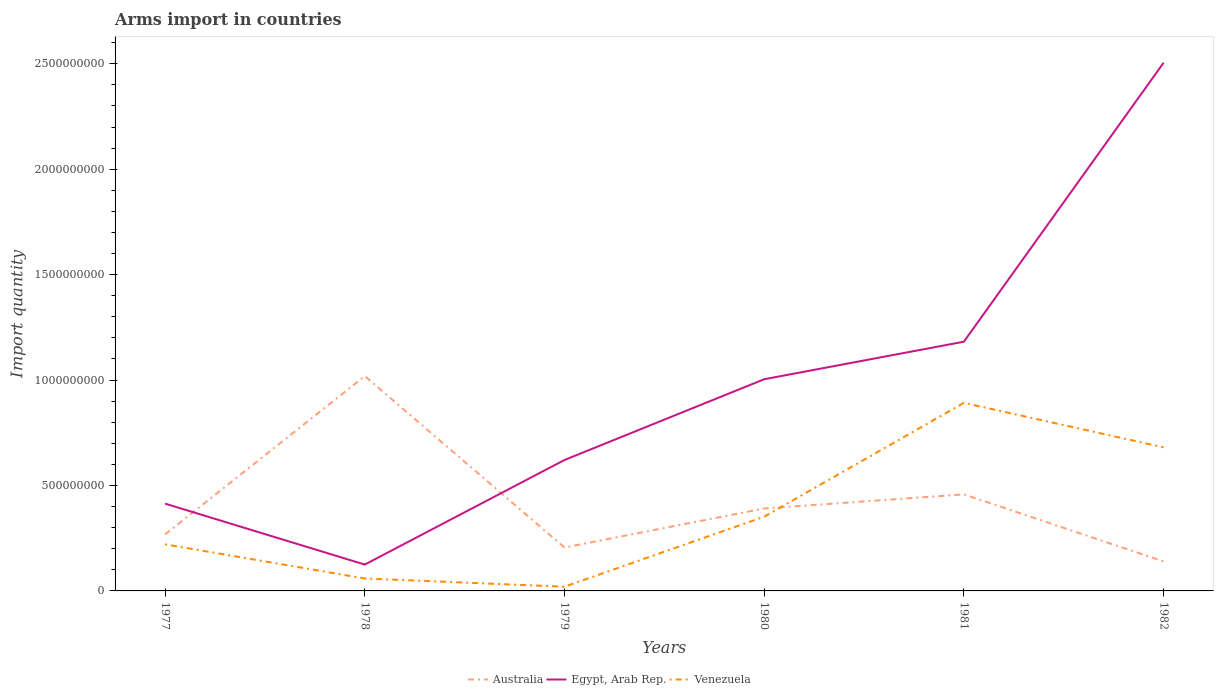Does the line corresponding to Egypt, Arab Rep. intersect with the line corresponding to Australia?
Your response must be concise. Yes. Is the number of lines equal to the number of legend labels?
Offer a very short reply. Yes. Across all years, what is the maximum total arms import in Egypt, Arab Rep.?
Your answer should be compact. 1.25e+08. In which year was the total arms import in Egypt, Arab Rep. maximum?
Provide a short and direct response. 1978. What is the total total arms import in Venezuela in the graph?
Offer a very short reply. -6.61e+08. What is the difference between the highest and the second highest total arms import in Australia?
Keep it short and to the point. 8.79e+08. How many lines are there?
Offer a terse response. 3. What is the difference between two consecutive major ticks on the Y-axis?
Ensure brevity in your answer.  5.00e+08. Are the values on the major ticks of Y-axis written in scientific E-notation?
Keep it short and to the point. No. Does the graph contain grids?
Keep it short and to the point. No. Where does the legend appear in the graph?
Give a very brief answer. Bottom center. What is the title of the graph?
Make the answer very short. Arms import in countries. What is the label or title of the X-axis?
Your answer should be compact. Years. What is the label or title of the Y-axis?
Provide a succinct answer. Import quantity. What is the Import quantity in Australia in 1977?
Offer a very short reply. 2.68e+08. What is the Import quantity in Egypt, Arab Rep. in 1977?
Your answer should be compact. 4.14e+08. What is the Import quantity in Venezuela in 1977?
Your answer should be very brief. 2.21e+08. What is the Import quantity of Australia in 1978?
Offer a very short reply. 1.02e+09. What is the Import quantity of Egypt, Arab Rep. in 1978?
Provide a short and direct response. 1.25e+08. What is the Import quantity of Venezuela in 1978?
Keep it short and to the point. 5.90e+07. What is the Import quantity in Australia in 1979?
Give a very brief answer. 2.06e+08. What is the Import quantity in Egypt, Arab Rep. in 1979?
Offer a very short reply. 6.21e+08. What is the Import quantity of Australia in 1980?
Provide a succinct answer. 3.91e+08. What is the Import quantity in Egypt, Arab Rep. in 1980?
Provide a short and direct response. 1.00e+09. What is the Import quantity in Venezuela in 1980?
Ensure brevity in your answer.  3.52e+08. What is the Import quantity in Australia in 1981?
Provide a short and direct response. 4.58e+08. What is the Import quantity in Egypt, Arab Rep. in 1981?
Your answer should be very brief. 1.18e+09. What is the Import quantity in Venezuela in 1981?
Offer a very short reply. 8.92e+08. What is the Import quantity in Australia in 1982?
Your response must be concise. 1.40e+08. What is the Import quantity in Egypt, Arab Rep. in 1982?
Ensure brevity in your answer.  2.50e+09. What is the Import quantity of Venezuela in 1982?
Your response must be concise. 6.81e+08. Across all years, what is the maximum Import quantity in Australia?
Keep it short and to the point. 1.02e+09. Across all years, what is the maximum Import quantity in Egypt, Arab Rep.?
Give a very brief answer. 2.50e+09. Across all years, what is the maximum Import quantity in Venezuela?
Offer a terse response. 8.92e+08. Across all years, what is the minimum Import quantity of Australia?
Provide a succinct answer. 1.40e+08. Across all years, what is the minimum Import quantity in Egypt, Arab Rep.?
Your response must be concise. 1.25e+08. Across all years, what is the minimum Import quantity of Venezuela?
Your answer should be very brief. 2.00e+07. What is the total Import quantity of Australia in the graph?
Your response must be concise. 2.48e+09. What is the total Import quantity of Egypt, Arab Rep. in the graph?
Your answer should be very brief. 5.85e+09. What is the total Import quantity in Venezuela in the graph?
Offer a very short reply. 2.22e+09. What is the difference between the Import quantity of Australia in 1977 and that in 1978?
Your answer should be very brief. -7.51e+08. What is the difference between the Import quantity in Egypt, Arab Rep. in 1977 and that in 1978?
Make the answer very short. 2.89e+08. What is the difference between the Import quantity in Venezuela in 1977 and that in 1978?
Give a very brief answer. 1.62e+08. What is the difference between the Import quantity in Australia in 1977 and that in 1979?
Offer a terse response. 6.20e+07. What is the difference between the Import quantity in Egypt, Arab Rep. in 1977 and that in 1979?
Provide a short and direct response. -2.07e+08. What is the difference between the Import quantity of Venezuela in 1977 and that in 1979?
Your answer should be very brief. 2.01e+08. What is the difference between the Import quantity in Australia in 1977 and that in 1980?
Ensure brevity in your answer.  -1.23e+08. What is the difference between the Import quantity of Egypt, Arab Rep. in 1977 and that in 1980?
Provide a short and direct response. -5.90e+08. What is the difference between the Import quantity of Venezuela in 1977 and that in 1980?
Ensure brevity in your answer.  -1.31e+08. What is the difference between the Import quantity in Australia in 1977 and that in 1981?
Your answer should be compact. -1.90e+08. What is the difference between the Import quantity of Egypt, Arab Rep. in 1977 and that in 1981?
Offer a very short reply. -7.68e+08. What is the difference between the Import quantity in Venezuela in 1977 and that in 1981?
Provide a succinct answer. -6.71e+08. What is the difference between the Import quantity in Australia in 1977 and that in 1982?
Offer a terse response. 1.28e+08. What is the difference between the Import quantity in Egypt, Arab Rep. in 1977 and that in 1982?
Your answer should be compact. -2.09e+09. What is the difference between the Import quantity of Venezuela in 1977 and that in 1982?
Your response must be concise. -4.60e+08. What is the difference between the Import quantity in Australia in 1978 and that in 1979?
Give a very brief answer. 8.13e+08. What is the difference between the Import quantity of Egypt, Arab Rep. in 1978 and that in 1979?
Give a very brief answer. -4.96e+08. What is the difference between the Import quantity in Venezuela in 1978 and that in 1979?
Give a very brief answer. 3.90e+07. What is the difference between the Import quantity in Australia in 1978 and that in 1980?
Offer a very short reply. 6.28e+08. What is the difference between the Import quantity of Egypt, Arab Rep. in 1978 and that in 1980?
Ensure brevity in your answer.  -8.79e+08. What is the difference between the Import quantity in Venezuela in 1978 and that in 1980?
Your answer should be very brief. -2.93e+08. What is the difference between the Import quantity of Australia in 1978 and that in 1981?
Make the answer very short. 5.61e+08. What is the difference between the Import quantity in Egypt, Arab Rep. in 1978 and that in 1981?
Provide a succinct answer. -1.06e+09. What is the difference between the Import quantity of Venezuela in 1978 and that in 1981?
Offer a terse response. -8.33e+08. What is the difference between the Import quantity of Australia in 1978 and that in 1982?
Make the answer very short. 8.79e+08. What is the difference between the Import quantity in Egypt, Arab Rep. in 1978 and that in 1982?
Provide a short and direct response. -2.38e+09. What is the difference between the Import quantity of Venezuela in 1978 and that in 1982?
Provide a short and direct response. -6.22e+08. What is the difference between the Import quantity of Australia in 1979 and that in 1980?
Offer a very short reply. -1.85e+08. What is the difference between the Import quantity of Egypt, Arab Rep. in 1979 and that in 1980?
Your answer should be very brief. -3.83e+08. What is the difference between the Import quantity of Venezuela in 1979 and that in 1980?
Offer a terse response. -3.32e+08. What is the difference between the Import quantity in Australia in 1979 and that in 1981?
Ensure brevity in your answer.  -2.52e+08. What is the difference between the Import quantity of Egypt, Arab Rep. in 1979 and that in 1981?
Provide a succinct answer. -5.61e+08. What is the difference between the Import quantity in Venezuela in 1979 and that in 1981?
Offer a terse response. -8.72e+08. What is the difference between the Import quantity of Australia in 1979 and that in 1982?
Offer a very short reply. 6.60e+07. What is the difference between the Import quantity of Egypt, Arab Rep. in 1979 and that in 1982?
Your answer should be very brief. -1.88e+09. What is the difference between the Import quantity in Venezuela in 1979 and that in 1982?
Your answer should be very brief. -6.61e+08. What is the difference between the Import quantity in Australia in 1980 and that in 1981?
Make the answer very short. -6.70e+07. What is the difference between the Import quantity of Egypt, Arab Rep. in 1980 and that in 1981?
Offer a terse response. -1.78e+08. What is the difference between the Import quantity of Venezuela in 1980 and that in 1981?
Provide a short and direct response. -5.40e+08. What is the difference between the Import quantity of Australia in 1980 and that in 1982?
Provide a succinct answer. 2.51e+08. What is the difference between the Import quantity in Egypt, Arab Rep. in 1980 and that in 1982?
Your answer should be very brief. -1.50e+09. What is the difference between the Import quantity of Venezuela in 1980 and that in 1982?
Your response must be concise. -3.29e+08. What is the difference between the Import quantity in Australia in 1981 and that in 1982?
Your answer should be compact. 3.18e+08. What is the difference between the Import quantity in Egypt, Arab Rep. in 1981 and that in 1982?
Provide a short and direct response. -1.32e+09. What is the difference between the Import quantity in Venezuela in 1981 and that in 1982?
Give a very brief answer. 2.11e+08. What is the difference between the Import quantity of Australia in 1977 and the Import quantity of Egypt, Arab Rep. in 1978?
Your answer should be very brief. 1.43e+08. What is the difference between the Import quantity in Australia in 1977 and the Import quantity in Venezuela in 1978?
Keep it short and to the point. 2.09e+08. What is the difference between the Import quantity in Egypt, Arab Rep. in 1977 and the Import quantity in Venezuela in 1978?
Your response must be concise. 3.55e+08. What is the difference between the Import quantity in Australia in 1977 and the Import quantity in Egypt, Arab Rep. in 1979?
Make the answer very short. -3.53e+08. What is the difference between the Import quantity in Australia in 1977 and the Import quantity in Venezuela in 1979?
Make the answer very short. 2.48e+08. What is the difference between the Import quantity of Egypt, Arab Rep. in 1977 and the Import quantity of Venezuela in 1979?
Ensure brevity in your answer.  3.94e+08. What is the difference between the Import quantity in Australia in 1977 and the Import quantity in Egypt, Arab Rep. in 1980?
Provide a short and direct response. -7.36e+08. What is the difference between the Import quantity in Australia in 1977 and the Import quantity in Venezuela in 1980?
Offer a terse response. -8.40e+07. What is the difference between the Import quantity in Egypt, Arab Rep. in 1977 and the Import quantity in Venezuela in 1980?
Give a very brief answer. 6.20e+07. What is the difference between the Import quantity of Australia in 1977 and the Import quantity of Egypt, Arab Rep. in 1981?
Give a very brief answer. -9.14e+08. What is the difference between the Import quantity in Australia in 1977 and the Import quantity in Venezuela in 1981?
Provide a short and direct response. -6.24e+08. What is the difference between the Import quantity of Egypt, Arab Rep. in 1977 and the Import quantity of Venezuela in 1981?
Give a very brief answer. -4.78e+08. What is the difference between the Import quantity in Australia in 1977 and the Import quantity in Egypt, Arab Rep. in 1982?
Provide a short and direct response. -2.24e+09. What is the difference between the Import quantity in Australia in 1977 and the Import quantity in Venezuela in 1982?
Provide a short and direct response. -4.13e+08. What is the difference between the Import quantity of Egypt, Arab Rep. in 1977 and the Import quantity of Venezuela in 1982?
Your answer should be compact. -2.67e+08. What is the difference between the Import quantity of Australia in 1978 and the Import quantity of Egypt, Arab Rep. in 1979?
Offer a very short reply. 3.98e+08. What is the difference between the Import quantity of Australia in 1978 and the Import quantity of Venezuela in 1979?
Make the answer very short. 9.99e+08. What is the difference between the Import quantity in Egypt, Arab Rep. in 1978 and the Import quantity in Venezuela in 1979?
Ensure brevity in your answer.  1.05e+08. What is the difference between the Import quantity in Australia in 1978 and the Import quantity in Egypt, Arab Rep. in 1980?
Offer a terse response. 1.50e+07. What is the difference between the Import quantity of Australia in 1978 and the Import quantity of Venezuela in 1980?
Give a very brief answer. 6.67e+08. What is the difference between the Import quantity of Egypt, Arab Rep. in 1978 and the Import quantity of Venezuela in 1980?
Give a very brief answer. -2.27e+08. What is the difference between the Import quantity of Australia in 1978 and the Import quantity of Egypt, Arab Rep. in 1981?
Your answer should be very brief. -1.63e+08. What is the difference between the Import quantity of Australia in 1978 and the Import quantity of Venezuela in 1981?
Offer a very short reply. 1.27e+08. What is the difference between the Import quantity in Egypt, Arab Rep. in 1978 and the Import quantity in Venezuela in 1981?
Give a very brief answer. -7.67e+08. What is the difference between the Import quantity of Australia in 1978 and the Import quantity of Egypt, Arab Rep. in 1982?
Provide a succinct answer. -1.49e+09. What is the difference between the Import quantity in Australia in 1978 and the Import quantity in Venezuela in 1982?
Offer a terse response. 3.38e+08. What is the difference between the Import quantity in Egypt, Arab Rep. in 1978 and the Import quantity in Venezuela in 1982?
Give a very brief answer. -5.56e+08. What is the difference between the Import quantity in Australia in 1979 and the Import quantity in Egypt, Arab Rep. in 1980?
Give a very brief answer. -7.98e+08. What is the difference between the Import quantity of Australia in 1979 and the Import quantity of Venezuela in 1980?
Your answer should be very brief. -1.46e+08. What is the difference between the Import quantity of Egypt, Arab Rep. in 1979 and the Import quantity of Venezuela in 1980?
Your answer should be very brief. 2.69e+08. What is the difference between the Import quantity in Australia in 1979 and the Import quantity in Egypt, Arab Rep. in 1981?
Your response must be concise. -9.76e+08. What is the difference between the Import quantity in Australia in 1979 and the Import quantity in Venezuela in 1981?
Make the answer very short. -6.86e+08. What is the difference between the Import quantity of Egypt, Arab Rep. in 1979 and the Import quantity of Venezuela in 1981?
Offer a terse response. -2.71e+08. What is the difference between the Import quantity of Australia in 1979 and the Import quantity of Egypt, Arab Rep. in 1982?
Make the answer very short. -2.30e+09. What is the difference between the Import quantity in Australia in 1979 and the Import quantity in Venezuela in 1982?
Your answer should be very brief. -4.75e+08. What is the difference between the Import quantity of Egypt, Arab Rep. in 1979 and the Import quantity of Venezuela in 1982?
Your response must be concise. -6.00e+07. What is the difference between the Import quantity of Australia in 1980 and the Import quantity of Egypt, Arab Rep. in 1981?
Ensure brevity in your answer.  -7.91e+08. What is the difference between the Import quantity of Australia in 1980 and the Import quantity of Venezuela in 1981?
Give a very brief answer. -5.01e+08. What is the difference between the Import quantity of Egypt, Arab Rep. in 1980 and the Import quantity of Venezuela in 1981?
Your answer should be compact. 1.12e+08. What is the difference between the Import quantity of Australia in 1980 and the Import quantity of Egypt, Arab Rep. in 1982?
Your answer should be compact. -2.11e+09. What is the difference between the Import quantity of Australia in 1980 and the Import quantity of Venezuela in 1982?
Keep it short and to the point. -2.90e+08. What is the difference between the Import quantity in Egypt, Arab Rep. in 1980 and the Import quantity in Venezuela in 1982?
Provide a short and direct response. 3.23e+08. What is the difference between the Import quantity in Australia in 1981 and the Import quantity in Egypt, Arab Rep. in 1982?
Keep it short and to the point. -2.05e+09. What is the difference between the Import quantity of Australia in 1981 and the Import quantity of Venezuela in 1982?
Keep it short and to the point. -2.23e+08. What is the difference between the Import quantity in Egypt, Arab Rep. in 1981 and the Import quantity in Venezuela in 1982?
Your answer should be compact. 5.01e+08. What is the average Import quantity of Australia per year?
Give a very brief answer. 4.14e+08. What is the average Import quantity in Egypt, Arab Rep. per year?
Your answer should be compact. 9.75e+08. What is the average Import quantity of Venezuela per year?
Provide a succinct answer. 3.71e+08. In the year 1977, what is the difference between the Import quantity of Australia and Import quantity of Egypt, Arab Rep.?
Your answer should be compact. -1.46e+08. In the year 1977, what is the difference between the Import quantity of Australia and Import quantity of Venezuela?
Keep it short and to the point. 4.70e+07. In the year 1977, what is the difference between the Import quantity in Egypt, Arab Rep. and Import quantity in Venezuela?
Make the answer very short. 1.93e+08. In the year 1978, what is the difference between the Import quantity of Australia and Import quantity of Egypt, Arab Rep.?
Your answer should be very brief. 8.94e+08. In the year 1978, what is the difference between the Import quantity of Australia and Import quantity of Venezuela?
Keep it short and to the point. 9.60e+08. In the year 1978, what is the difference between the Import quantity of Egypt, Arab Rep. and Import quantity of Venezuela?
Provide a short and direct response. 6.60e+07. In the year 1979, what is the difference between the Import quantity of Australia and Import quantity of Egypt, Arab Rep.?
Make the answer very short. -4.15e+08. In the year 1979, what is the difference between the Import quantity in Australia and Import quantity in Venezuela?
Offer a terse response. 1.86e+08. In the year 1979, what is the difference between the Import quantity of Egypt, Arab Rep. and Import quantity of Venezuela?
Keep it short and to the point. 6.01e+08. In the year 1980, what is the difference between the Import quantity of Australia and Import quantity of Egypt, Arab Rep.?
Your response must be concise. -6.13e+08. In the year 1980, what is the difference between the Import quantity in Australia and Import quantity in Venezuela?
Offer a very short reply. 3.90e+07. In the year 1980, what is the difference between the Import quantity of Egypt, Arab Rep. and Import quantity of Venezuela?
Your response must be concise. 6.52e+08. In the year 1981, what is the difference between the Import quantity in Australia and Import quantity in Egypt, Arab Rep.?
Provide a succinct answer. -7.24e+08. In the year 1981, what is the difference between the Import quantity of Australia and Import quantity of Venezuela?
Provide a succinct answer. -4.34e+08. In the year 1981, what is the difference between the Import quantity of Egypt, Arab Rep. and Import quantity of Venezuela?
Your response must be concise. 2.90e+08. In the year 1982, what is the difference between the Import quantity in Australia and Import quantity in Egypt, Arab Rep.?
Provide a succinct answer. -2.36e+09. In the year 1982, what is the difference between the Import quantity in Australia and Import quantity in Venezuela?
Give a very brief answer. -5.41e+08. In the year 1982, what is the difference between the Import quantity of Egypt, Arab Rep. and Import quantity of Venezuela?
Give a very brief answer. 1.82e+09. What is the ratio of the Import quantity in Australia in 1977 to that in 1978?
Provide a succinct answer. 0.26. What is the ratio of the Import quantity of Egypt, Arab Rep. in 1977 to that in 1978?
Your response must be concise. 3.31. What is the ratio of the Import quantity in Venezuela in 1977 to that in 1978?
Your answer should be compact. 3.75. What is the ratio of the Import quantity of Australia in 1977 to that in 1979?
Provide a short and direct response. 1.3. What is the ratio of the Import quantity in Egypt, Arab Rep. in 1977 to that in 1979?
Ensure brevity in your answer.  0.67. What is the ratio of the Import quantity of Venezuela in 1977 to that in 1979?
Offer a very short reply. 11.05. What is the ratio of the Import quantity in Australia in 1977 to that in 1980?
Your answer should be very brief. 0.69. What is the ratio of the Import quantity of Egypt, Arab Rep. in 1977 to that in 1980?
Offer a terse response. 0.41. What is the ratio of the Import quantity of Venezuela in 1977 to that in 1980?
Offer a very short reply. 0.63. What is the ratio of the Import quantity in Australia in 1977 to that in 1981?
Make the answer very short. 0.59. What is the ratio of the Import quantity of Egypt, Arab Rep. in 1977 to that in 1981?
Your answer should be compact. 0.35. What is the ratio of the Import quantity in Venezuela in 1977 to that in 1981?
Your response must be concise. 0.25. What is the ratio of the Import quantity of Australia in 1977 to that in 1982?
Offer a very short reply. 1.91. What is the ratio of the Import quantity of Egypt, Arab Rep. in 1977 to that in 1982?
Make the answer very short. 0.17. What is the ratio of the Import quantity in Venezuela in 1977 to that in 1982?
Give a very brief answer. 0.32. What is the ratio of the Import quantity in Australia in 1978 to that in 1979?
Ensure brevity in your answer.  4.95. What is the ratio of the Import quantity in Egypt, Arab Rep. in 1978 to that in 1979?
Provide a succinct answer. 0.2. What is the ratio of the Import quantity of Venezuela in 1978 to that in 1979?
Give a very brief answer. 2.95. What is the ratio of the Import quantity in Australia in 1978 to that in 1980?
Give a very brief answer. 2.61. What is the ratio of the Import quantity of Egypt, Arab Rep. in 1978 to that in 1980?
Your answer should be very brief. 0.12. What is the ratio of the Import quantity of Venezuela in 1978 to that in 1980?
Offer a very short reply. 0.17. What is the ratio of the Import quantity in Australia in 1978 to that in 1981?
Your response must be concise. 2.22. What is the ratio of the Import quantity of Egypt, Arab Rep. in 1978 to that in 1981?
Give a very brief answer. 0.11. What is the ratio of the Import quantity of Venezuela in 1978 to that in 1981?
Provide a succinct answer. 0.07. What is the ratio of the Import quantity in Australia in 1978 to that in 1982?
Offer a terse response. 7.28. What is the ratio of the Import quantity of Egypt, Arab Rep. in 1978 to that in 1982?
Ensure brevity in your answer.  0.05. What is the ratio of the Import quantity in Venezuela in 1978 to that in 1982?
Ensure brevity in your answer.  0.09. What is the ratio of the Import quantity of Australia in 1979 to that in 1980?
Provide a short and direct response. 0.53. What is the ratio of the Import quantity in Egypt, Arab Rep. in 1979 to that in 1980?
Keep it short and to the point. 0.62. What is the ratio of the Import quantity in Venezuela in 1979 to that in 1980?
Provide a short and direct response. 0.06. What is the ratio of the Import quantity of Australia in 1979 to that in 1981?
Give a very brief answer. 0.45. What is the ratio of the Import quantity in Egypt, Arab Rep. in 1979 to that in 1981?
Your answer should be very brief. 0.53. What is the ratio of the Import quantity of Venezuela in 1979 to that in 1981?
Your answer should be very brief. 0.02. What is the ratio of the Import quantity of Australia in 1979 to that in 1982?
Offer a very short reply. 1.47. What is the ratio of the Import quantity of Egypt, Arab Rep. in 1979 to that in 1982?
Offer a very short reply. 0.25. What is the ratio of the Import quantity of Venezuela in 1979 to that in 1982?
Ensure brevity in your answer.  0.03. What is the ratio of the Import quantity of Australia in 1980 to that in 1981?
Make the answer very short. 0.85. What is the ratio of the Import quantity of Egypt, Arab Rep. in 1980 to that in 1981?
Your response must be concise. 0.85. What is the ratio of the Import quantity in Venezuela in 1980 to that in 1981?
Your answer should be very brief. 0.39. What is the ratio of the Import quantity in Australia in 1980 to that in 1982?
Keep it short and to the point. 2.79. What is the ratio of the Import quantity in Egypt, Arab Rep. in 1980 to that in 1982?
Provide a succinct answer. 0.4. What is the ratio of the Import quantity in Venezuela in 1980 to that in 1982?
Give a very brief answer. 0.52. What is the ratio of the Import quantity of Australia in 1981 to that in 1982?
Your answer should be very brief. 3.27. What is the ratio of the Import quantity in Egypt, Arab Rep. in 1981 to that in 1982?
Offer a terse response. 0.47. What is the ratio of the Import quantity of Venezuela in 1981 to that in 1982?
Your answer should be very brief. 1.31. What is the difference between the highest and the second highest Import quantity in Australia?
Keep it short and to the point. 5.61e+08. What is the difference between the highest and the second highest Import quantity of Egypt, Arab Rep.?
Offer a very short reply. 1.32e+09. What is the difference between the highest and the second highest Import quantity in Venezuela?
Your answer should be very brief. 2.11e+08. What is the difference between the highest and the lowest Import quantity in Australia?
Make the answer very short. 8.79e+08. What is the difference between the highest and the lowest Import quantity in Egypt, Arab Rep.?
Your response must be concise. 2.38e+09. What is the difference between the highest and the lowest Import quantity in Venezuela?
Provide a short and direct response. 8.72e+08. 